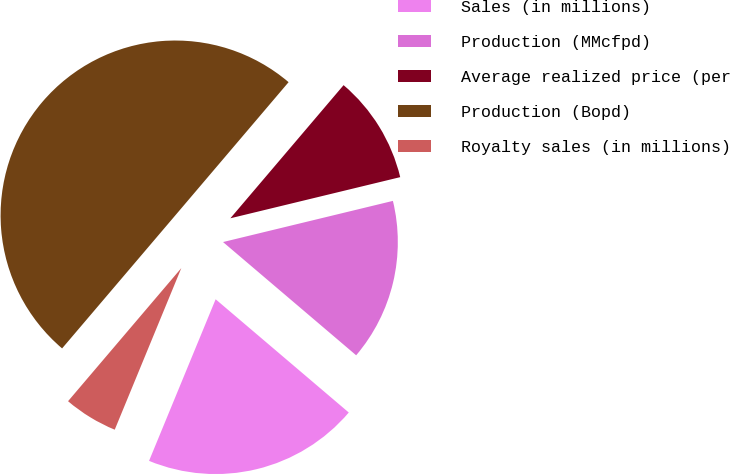Convert chart. <chart><loc_0><loc_0><loc_500><loc_500><pie_chart><fcel>Sales (in millions)<fcel>Production (MMcfpd)<fcel>Average realized price (per<fcel>Production (Bopd)<fcel>Royalty sales (in millions)<nl><fcel>20.0%<fcel>15.0%<fcel>10.0%<fcel>49.99%<fcel>5.0%<nl></chart> 